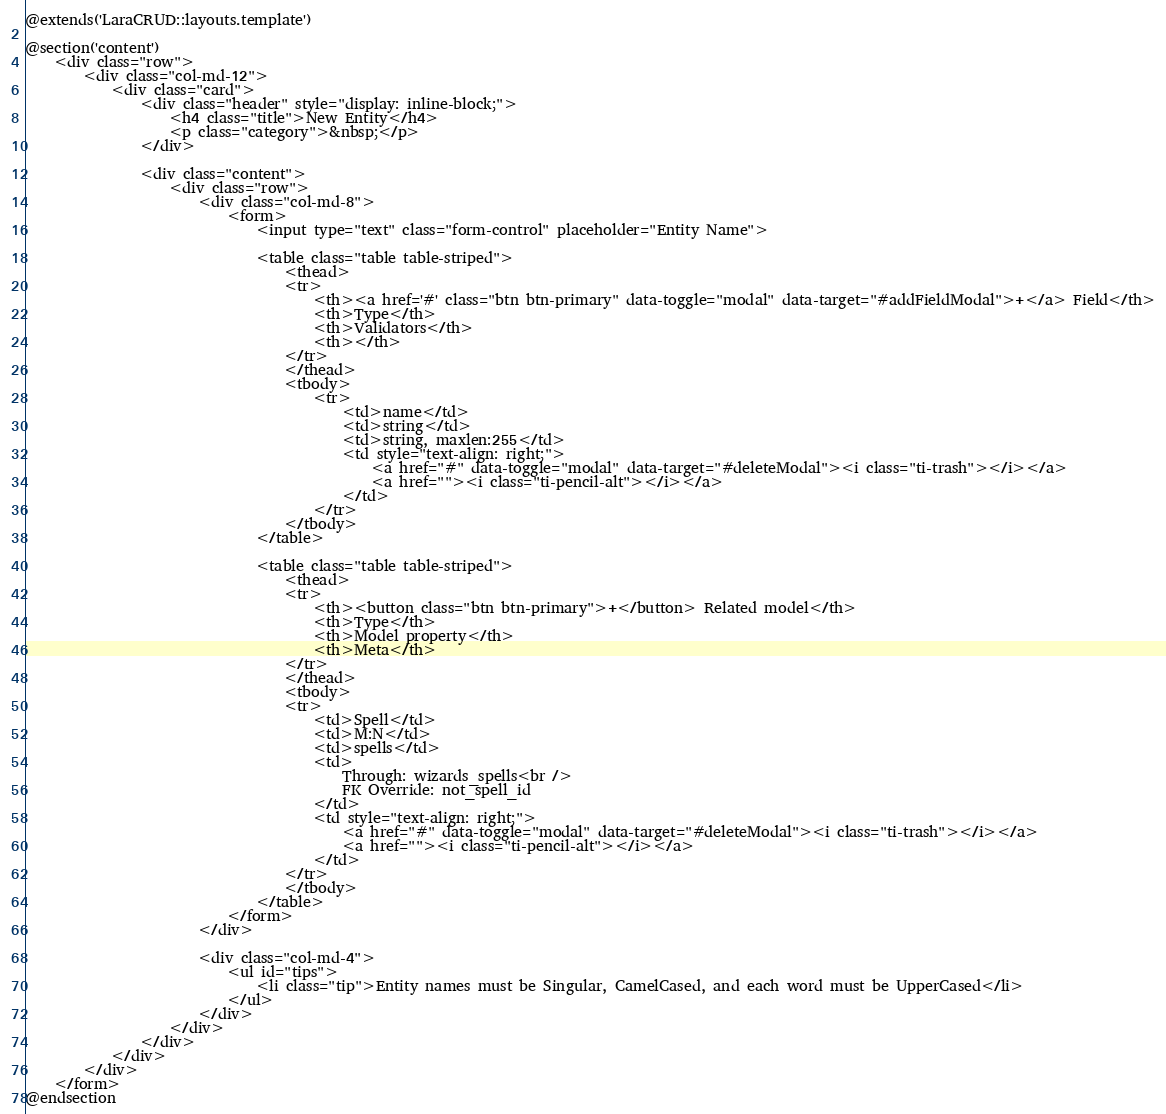<code> <loc_0><loc_0><loc_500><loc_500><_PHP_>@extends('LaraCRUD::layouts.template')

@section('content')
    <div class="row">
        <div class="col-md-12">
            <div class="card">
                <div class="header" style="display: inline-block;">
                    <h4 class="title">New Entity</h4>
                    <p class="category">&nbsp;</p>
                </div>

                <div class="content">
                    <div class="row">
                        <div class="col-md-8">
                            <form>
                                <input type="text" class="form-control" placeholder="Entity Name">

                                <table class="table table-striped">
                                    <thead>
                                    <tr>
                                        <th><a href='#' class="btn btn-primary" data-toggle="modal" data-target="#addFieldModal">+</a> Field</th>
                                        <th>Type</th>
                                        <th>Validators</th>
                                        <th></th>
                                    </tr>
                                    </thead>
                                    <tbody>
                                        <tr>
                                            <td>name</td>
                                            <td>string</td>
                                            <td>string, maxlen:255</td>
                                            <td style="text-align: right;">
                                                <a href="#" data-toggle="modal" data-target="#deleteModal"><i class="ti-trash"></i></a>
                                                <a href=""><i class="ti-pencil-alt"></i></a>
                                            </td>
                                        </tr>
                                    </tbody>
                                </table>

                                <table class="table table-striped">
                                    <thead>
                                    <tr>
                                        <th><button class="btn btn-primary">+</button> Related model</th>
                                        <th>Type</th>
                                        <th>Model property</th>
                                        <th>Meta</th>
                                    </tr>
                                    </thead>
                                    <tbody>
                                    <tr>
                                        <td>Spell</td>
                                        <td>M:N</td>
                                        <td>spells</td>
                                        <td>
                                            Through: wizards_spells<br />
                                            FK Override: not_spell_id
                                        </td>
                                        <td style="text-align: right;">
                                            <a href="#" data-toggle="modal" data-target="#deleteModal"><i class="ti-trash"></i></a>
                                            <a href=""><i class="ti-pencil-alt"></i></a>
                                        </td>
                                    </tr>
                                    </tbody>
                                </table>
                            </form>
                        </div>

                        <div class="col-md-4">
                            <ul id="tips">
                                <li class="tip">Entity names must be Singular, CamelCased, and each word must be UpperCased</li>
                            </ul>
                        </div>
                    </div>
                </div>
            </div>
        </div>
    </form>
@endsection</code> 